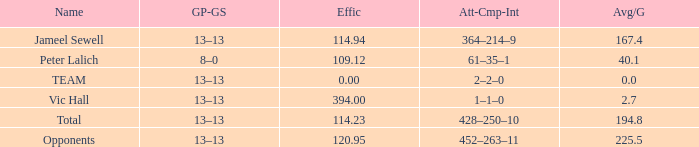Avg per game below 22 Peter Lalich. 